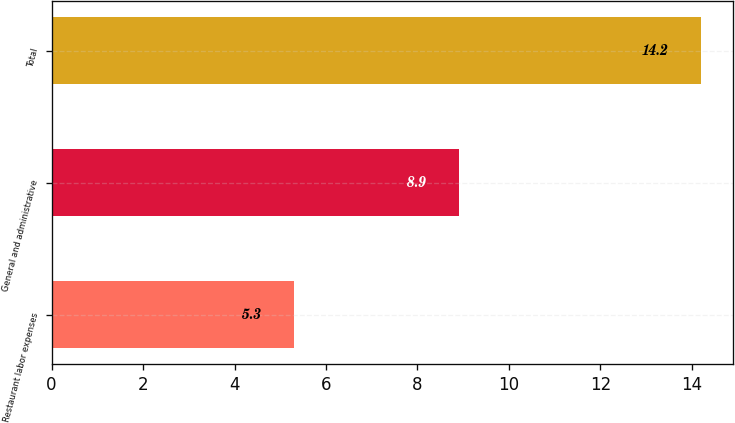Convert chart. <chart><loc_0><loc_0><loc_500><loc_500><bar_chart><fcel>Restaurant labor expenses<fcel>General and administrative<fcel>Total<nl><fcel>5.3<fcel>8.9<fcel>14.2<nl></chart> 